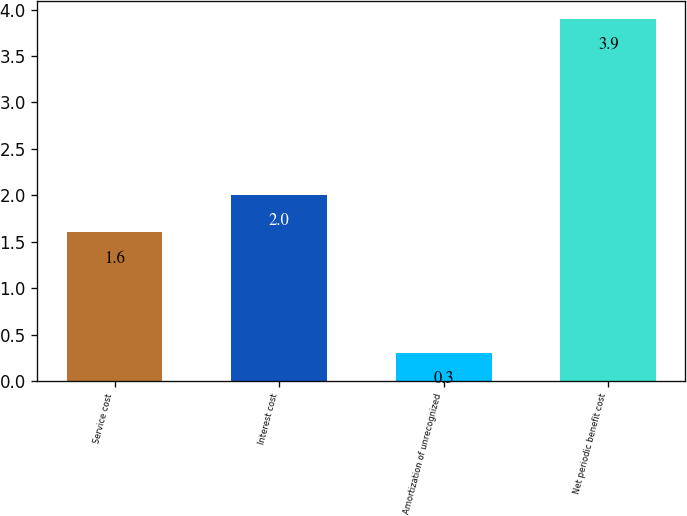Convert chart to OTSL. <chart><loc_0><loc_0><loc_500><loc_500><bar_chart><fcel>Service cost<fcel>Interest cost<fcel>Amortization of unrecognized<fcel>Net periodic benefit cost<nl><fcel>1.6<fcel>2<fcel>0.3<fcel>3.9<nl></chart> 